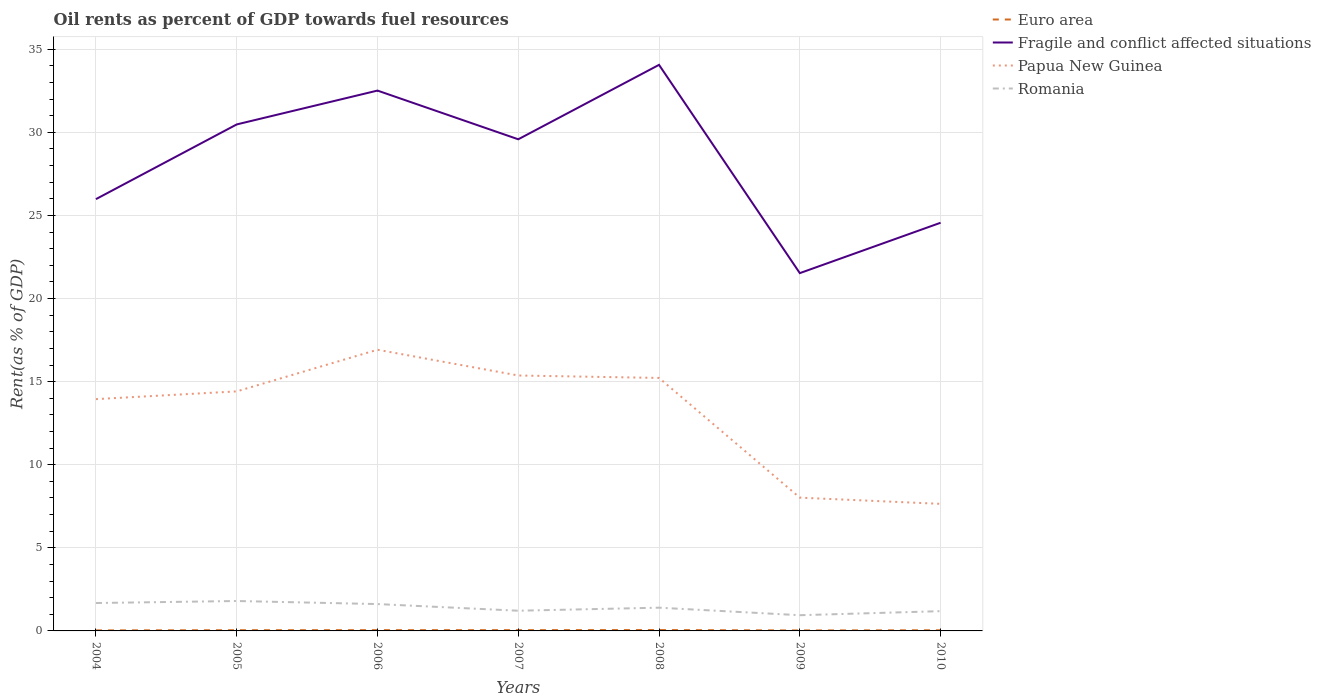Is the number of lines equal to the number of legend labels?
Make the answer very short. Yes. Across all years, what is the maximum oil rent in Euro area?
Keep it short and to the point. 0.03. What is the total oil rent in Papua New Guinea in the graph?
Ensure brevity in your answer.  7.72. What is the difference between the highest and the second highest oil rent in Fragile and conflict affected situations?
Your response must be concise. 12.53. What is the difference between the highest and the lowest oil rent in Fragile and conflict affected situations?
Make the answer very short. 4. Are the values on the major ticks of Y-axis written in scientific E-notation?
Give a very brief answer. No. How are the legend labels stacked?
Provide a succinct answer. Vertical. What is the title of the graph?
Ensure brevity in your answer.  Oil rents as percent of GDP towards fuel resources. Does "Micronesia" appear as one of the legend labels in the graph?
Give a very brief answer. No. What is the label or title of the Y-axis?
Ensure brevity in your answer.  Rent(as % of GDP). What is the Rent(as % of GDP) in Euro area in 2004?
Your answer should be compact. 0.03. What is the Rent(as % of GDP) in Fragile and conflict affected situations in 2004?
Your answer should be compact. 25.98. What is the Rent(as % of GDP) of Papua New Guinea in 2004?
Offer a very short reply. 13.95. What is the Rent(as % of GDP) of Romania in 2004?
Provide a short and direct response. 1.68. What is the Rent(as % of GDP) in Euro area in 2005?
Provide a succinct answer. 0.04. What is the Rent(as % of GDP) in Fragile and conflict affected situations in 2005?
Offer a terse response. 30.48. What is the Rent(as % of GDP) of Papua New Guinea in 2005?
Your answer should be very brief. 14.41. What is the Rent(as % of GDP) in Romania in 2005?
Offer a terse response. 1.8. What is the Rent(as % of GDP) in Euro area in 2006?
Offer a terse response. 0.05. What is the Rent(as % of GDP) in Fragile and conflict affected situations in 2006?
Your response must be concise. 32.51. What is the Rent(as % of GDP) of Papua New Guinea in 2006?
Offer a terse response. 16.92. What is the Rent(as % of GDP) in Romania in 2006?
Offer a terse response. 1.62. What is the Rent(as % of GDP) in Euro area in 2007?
Ensure brevity in your answer.  0.05. What is the Rent(as % of GDP) of Fragile and conflict affected situations in 2007?
Offer a terse response. 29.58. What is the Rent(as % of GDP) of Papua New Guinea in 2007?
Make the answer very short. 15.37. What is the Rent(as % of GDP) of Romania in 2007?
Your answer should be compact. 1.22. What is the Rent(as % of GDP) of Euro area in 2008?
Give a very brief answer. 0.05. What is the Rent(as % of GDP) of Fragile and conflict affected situations in 2008?
Provide a succinct answer. 34.06. What is the Rent(as % of GDP) of Papua New Guinea in 2008?
Offer a very short reply. 15.22. What is the Rent(as % of GDP) in Romania in 2008?
Offer a terse response. 1.4. What is the Rent(as % of GDP) in Euro area in 2009?
Provide a succinct answer. 0.03. What is the Rent(as % of GDP) in Fragile and conflict affected situations in 2009?
Your answer should be very brief. 21.53. What is the Rent(as % of GDP) in Papua New Guinea in 2009?
Offer a very short reply. 8.02. What is the Rent(as % of GDP) in Romania in 2009?
Your response must be concise. 0.95. What is the Rent(as % of GDP) in Euro area in 2010?
Make the answer very short. 0.04. What is the Rent(as % of GDP) in Fragile and conflict affected situations in 2010?
Offer a terse response. 24.56. What is the Rent(as % of GDP) in Papua New Guinea in 2010?
Provide a succinct answer. 7.65. What is the Rent(as % of GDP) of Romania in 2010?
Provide a short and direct response. 1.19. Across all years, what is the maximum Rent(as % of GDP) in Euro area?
Ensure brevity in your answer.  0.05. Across all years, what is the maximum Rent(as % of GDP) in Fragile and conflict affected situations?
Your answer should be very brief. 34.06. Across all years, what is the maximum Rent(as % of GDP) of Papua New Guinea?
Your answer should be very brief. 16.92. Across all years, what is the maximum Rent(as % of GDP) in Romania?
Your answer should be compact. 1.8. Across all years, what is the minimum Rent(as % of GDP) in Euro area?
Provide a succinct answer. 0.03. Across all years, what is the minimum Rent(as % of GDP) in Fragile and conflict affected situations?
Ensure brevity in your answer.  21.53. Across all years, what is the minimum Rent(as % of GDP) in Papua New Guinea?
Provide a short and direct response. 7.65. Across all years, what is the minimum Rent(as % of GDP) of Romania?
Offer a terse response. 0.95. What is the total Rent(as % of GDP) in Euro area in the graph?
Your response must be concise. 0.29. What is the total Rent(as % of GDP) of Fragile and conflict affected situations in the graph?
Ensure brevity in your answer.  198.7. What is the total Rent(as % of GDP) in Papua New Guinea in the graph?
Your response must be concise. 91.53. What is the total Rent(as % of GDP) in Romania in the graph?
Make the answer very short. 9.84. What is the difference between the Rent(as % of GDP) of Euro area in 2004 and that in 2005?
Ensure brevity in your answer.  -0.01. What is the difference between the Rent(as % of GDP) of Fragile and conflict affected situations in 2004 and that in 2005?
Provide a succinct answer. -4.5. What is the difference between the Rent(as % of GDP) of Papua New Guinea in 2004 and that in 2005?
Offer a terse response. -0.47. What is the difference between the Rent(as % of GDP) of Romania in 2004 and that in 2005?
Give a very brief answer. -0.12. What is the difference between the Rent(as % of GDP) in Euro area in 2004 and that in 2006?
Offer a very short reply. -0.02. What is the difference between the Rent(as % of GDP) in Fragile and conflict affected situations in 2004 and that in 2006?
Give a very brief answer. -6.53. What is the difference between the Rent(as % of GDP) in Papua New Guinea in 2004 and that in 2006?
Offer a very short reply. -2.97. What is the difference between the Rent(as % of GDP) in Romania in 2004 and that in 2006?
Keep it short and to the point. 0.06. What is the difference between the Rent(as % of GDP) of Euro area in 2004 and that in 2007?
Provide a short and direct response. -0.02. What is the difference between the Rent(as % of GDP) of Fragile and conflict affected situations in 2004 and that in 2007?
Give a very brief answer. -3.6. What is the difference between the Rent(as % of GDP) of Papua New Guinea in 2004 and that in 2007?
Provide a short and direct response. -1.42. What is the difference between the Rent(as % of GDP) of Romania in 2004 and that in 2007?
Your answer should be very brief. 0.46. What is the difference between the Rent(as % of GDP) in Euro area in 2004 and that in 2008?
Ensure brevity in your answer.  -0.02. What is the difference between the Rent(as % of GDP) of Fragile and conflict affected situations in 2004 and that in 2008?
Make the answer very short. -8.08. What is the difference between the Rent(as % of GDP) in Papua New Guinea in 2004 and that in 2008?
Give a very brief answer. -1.27. What is the difference between the Rent(as % of GDP) of Romania in 2004 and that in 2008?
Make the answer very short. 0.28. What is the difference between the Rent(as % of GDP) of Euro area in 2004 and that in 2009?
Provide a short and direct response. 0. What is the difference between the Rent(as % of GDP) of Fragile and conflict affected situations in 2004 and that in 2009?
Provide a succinct answer. 4.45. What is the difference between the Rent(as % of GDP) in Papua New Guinea in 2004 and that in 2009?
Your answer should be compact. 5.93. What is the difference between the Rent(as % of GDP) in Romania in 2004 and that in 2009?
Your answer should be very brief. 0.73. What is the difference between the Rent(as % of GDP) in Euro area in 2004 and that in 2010?
Ensure brevity in your answer.  -0.01. What is the difference between the Rent(as % of GDP) in Fragile and conflict affected situations in 2004 and that in 2010?
Ensure brevity in your answer.  1.42. What is the difference between the Rent(as % of GDP) of Papua New Guinea in 2004 and that in 2010?
Provide a succinct answer. 6.3. What is the difference between the Rent(as % of GDP) in Romania in 2004 and that in 2010?
Keep it short and to the point. 0.49. What is the difference between the Rent(as % of GDP) in Euro area in 2005 and that in 2006?
Keep it short and to the point. -0. What is the difference between the Rent(as % of GDP) of Fragile and conflict affected situations in 2005 and that in 2006?
Provide a succinct answer. -2.04. What is the difference between the Rent(as % of GDP) in Papua New Guinea in 2005 and that in 2006?
Your answer should be very brief. -2.51. What is the difference between the Rent(as % of GDP) of Romania in 2005 and that in 2006?
Keep it short and to the point. 0.18. What is the difference between the Rent(as % of GDP) of Euro area in 2005 and that in 2007?
Ensure brevity in your answer.  -0. What is the difference between the Rent(as % of GDP) of Fragile and conflict affected situations in 2005 and that in 2007?
Provide a succinct answer. 0.89. What is the difference between the Rent(as % of GDP) of Papua New Guinea in 2005 and that in 2007?
Keep it short and to the point. -0.96. What is the difference between the Rent(as % of GDP) of Romania in 2005 and that in 2007?
Offer a very short reply. 0.58. What is the difference between the Rent(as % of GDP) of Euro area in 2005 and that in 2008?
Make the answer very short. -0.01. What is the difference between the Rent(as % of GDP) of Fragile and conflict affected situations in 2005 and that in 2008?
Offer a very short reply. -3.58. What is the difference between the Rent(as % of GDP) in Papua New Guinea in 2005 and that in 2008?
Provide a succinct answer. -0.81. What is the difference between the Rent(as % of GDP) of Romania in 2005 and that in 2008?
Ensure brevity in your answer.  0.4. What is the difference between the Rent(as % of GDP) of Euro area in 2005 and that in 2009?
Your answer should be compact. 0.01. What is the difference between the Rent(as % of GDP) in Fragile and conflict affected situations in 2005 and that in 2009?
Keep it short and to the point. 8.95. What is the difference between the Rent(as % of GDP) of Papua New Guinea in 2005 and that in 2009?
Keep it short and to the point. 6.39. What is the difference between the Rent(as % of GDP) in Romania in 2005 and that in 2009?
Ensure brevity in your answer.  0.85. What is the difference between the Rent(as % of GDP) in Euro area in 2005 and that in 2010?
Your response must be concise. 0. What is the difference between the Rent(as % of GDP) in Fragile and conflict affected situations in 2005 and that in 2010?
Offer a very short reply. 5.92. What is the difference between the Rent(as % of GDP) of Papua New Guinea in 2005 and that in 2010?
Your response must be concise. 6.77. What is the difference between the Rent(as % of GDP) of Romania in 2005 and that in 2010?
Your answer should be very brief. 0.61. What is the difference between the Rent(as % of GDP) in Euro area in 2006 and that in 2007?
Give a very brief answer. -0. What is the difference between the Rent(as % of GDP) of Fragile and conflict affected situations in 2006 and that in 2007?
Provide a succinct answer. 2.93. What is the difference between the Rent(as % of GDP) in Papua New Guinea in 2006 and that in 2007?
Offer a terse response. 1.55. What is the difference between the Rent(as % of GDP) of Romania in 2006 and that in 2007?
Your answer should be very brief. 0.4. What is the difference between the Rent(as % of GDP) of Euro area in 2006 and that in 2008?
Your answer should be compact. -0.01. What is the difference between the Rent(as % of GDP) of Fragile and conflict affected situations in 2006 and that in 2008?
Offer a very short reply. -1.55. What is the difference between the Rent(as % of GDP) in Papua New Guinea in 2006 and that in 2008?
Keep it short and to the point. 1.7. What is the difference between the Rent(as % of GDP) in Romania in 2006 and that in 2008?
Your response must be concise. 0.22. What is the difference between the Rent(as % of GDP) of Euro area in 2006 and that in 2009?
Ensure brevity in your answer.  0.02. What is the difference between the Rent(as % of GDP) of Fragile and conflict affected situations in 2006 and that in 2009?
Give a very brief answer. 10.98. What is the difference between the Rent(as % of GDP) in Papua New Guinea in 2006 and that in 2009?
Your answer should be very brief. 8.9. What is the difference between the Rent(as % of GDP) in Romania in 2006 and that in 2009?
Give a very brief answer. 0.67. What is the difference between the Rent(as % of GDP) in Euro area in 2006 and that in 2010?
Offer a very short reply. 0.01. What is the difference between the Rent(as % of GDP) of Fragile and conflict affected situations in 2006 and that in 2010?
Provide a short and direct response. 7.95. What is the difference between the Rent(as % of GDP) of Papua New Guinea in 2006 and that in 2010?
Your response must be concise. 9.27. What is the difference between the Rent(as % of GDP) of Romania in 2006 and that in 2010?
Provide a succinct answer. 0.43. What is the difference between the Rent(as % of GDP) in Euro area in 2007 and that in 2008?
Give a very brief answer. -0.01. What is the difference between the Rent(as % of GDP) in Fragile and conflict affected situations in 2007 and that in 2008?
Keep it short and to the point. -4.48. What is the difference between the Rent(as % of GDP) of Papua New Guinea in 2007 and that in 2008?
Provide a succinct answer. 0.15. What is the difference between the Rent(as % of GDP) in Romania in 2007 and that in 2008?
Your response must be concise. -0.18. What is the difference between the Rent(as % of GDP) of Euro area in 2007 and that in 2009?
Ensure brevity in your answer.  0.02. What is the difference between the Rent(as % of GDP) in Fragile and conflict affected situations in 2007 and that in 2009?
Offer a very short reply. 8.05. What is the difference between the Rent(as % of GDP) in Papua New Guinea in 2007 and that in 2009?
Give a very brief answer. 7.35. What is the difference between the Rent(as % of GDP) of Romania in 2007 and that in 2009?
Offer a terse response. 0.27. What is the difference between the Rent(as % of GDP) of Euro area in 2007 and that in 2010?
Provide a succinct answer. 0.01. What is the difference between the Rent(as % of GDP) in Fragile and conflict affected situations in 2007 and that in 2010?
Offer a terse response. 5.02. What is the difference between the Rent(as % of GDP) of Papua New Guinea in 2007 and that in 2010?
Offer a terse response. 7.72. What is the difference between the Rent(as % of GDP) in Romania in 2007 and that in 2010?
Ensure brevity in your answer.  0.03. What is the difference between the Rent(as % of GDP) of Euro area in 2008 and that in 2009?
Provide a short and direct response. 0.02. What is the difference between the Rent(as % of GDP) of Fragile and conflict affected situations in 2008 and that in 2009?
Offer a very short reply. 12.53. What is the difference between the Rent(as % of GDP) in Papua New Guinea in 2008 and that in 2009?
Make the answer very short. 7.2. What is the difference between the Rent(as % of GDP) in Romania in 2008 and that in 2009?
Keep it short and to the point. 0.45. What is the difference between the Rent(as % of GDP) of Euro area in 2008 and that in 2010?
Your answer should be very brief. 0.01. What is the difference between the Rent(as % of GDP) in Fragile and conflict affected situations in 2008 and that in 2010?
Ensure brevity in your answer.  9.5. What is the difference between the Rent(as % of GDP) of Papua New Guinea in 2008 and that in 2010?
Offer a terse response. 7.58. What is the difference between the Rent(as % of GDP) of Romania in 2008 and that in 2010?
Provide a short and direct response. 0.21. What is the difference between the Rent(as % of GDP) in Euro area in 2009 and that in 2010?
Ensure brevity in your answer.  -0.01. What is the difference between the Rent(as % of GDP) of Fragile and conflict affected situations in 2009 and that in 2010?
Offer a terse response. -3.03. What is the difference between the Rent(as % of GDP) in Papua New Guinea in 2009 and that in 2010?
Give a very brief answer. 0.37. What is the difference between the Rent(as % of GDP) of Romania in 2009 and that in 2010?
Your answer should be very brief. -0.24. What is the difference between the Rent(as % of GDP) of Euro area in 2004 and the Rent(as % of GDP) of Fragile and conflict affected situations in 2005?
Provide a succinct answer. -30.44. What is the difference between the Rent(as % of GDP) in Euro area in 2004 and the Rent(as % of GDP) in Papua New Guinea in 2005?
Provide a short and direct response. -14.38. What is the difference between the Rent(as % of GDP) in Euro area in 2004 and the Rent(as % of GDP) in Romania in 2005?
Offer a terse response. -1.77. What is the difference between the Rent(as % of GDP) in Fragile and conflict affected situations in 2004 and the Rent(as % of GDP) in Papua New Guinea in 2005?
Make the answer very short. 11.57. What is the difference between the Rent(as % of GDP) of Fragile and conflict affected situations in 2004 and the Rent(as % of GDP) of Romania in 2005?
Provide a succinct answer. 24.18. What is the difference between the Rent(as % of GDP) in Papua New Guinea in 2004 and the Rent(as % of GDP) in Romania in 2005?
Your answer should be very brief. 12.15. What is the difference between the Rent(as % of GDP) of Euro area in 2004 and the Rent(as % of GDP) of Fragile and conflict affected situations in 2006?
Give a very brief answer. -32.48. What is the difference between the Rent(as % of GDP) in Euro area in 2004 and the Rent(as % of GDP) in Papua New Guinea in 2006?
Keep it short and to the point. -16.89. What is the difference between the Rent(as % of GDP) in Euro area in 2004 and the Rent(as % of GDP) in Romania in 2006?
Your answer should be very brief. -1.58. What is the difference between the Rent(as % of GDP) of Fragile and conflict affected situations in 2004 and the Rent(as % of GDP) of Papua New Guinea in 2006?
Your response must be concise. 9.06. What is the difference between the Rent(as % of GDP) in Fragile and conflict affected situations in 2004 and the Rent(as % of GDP) in Romania in 2006?
Give a very brief answer. 24.36. What is the difference between the Rent(as % of GDP) of Papua New Guinea in 2004 and the Rent(as % of GDP) of Romania in 2006?
Your answer should be compact. 12.33. What is the difference between the Rent(as % of GDP) in Euro area in 2004 and the Rent(as % of GDP) in Fragile and conflict affected situations in 2007?
Your answer should be compact. -29.55. What is the difference between the Rent(as % of GDP) in Euro area in 2004 and the Rent(as % of GDP) in Papua New Guinea in 2007?
Your response must be concise. -15.34. What is the difference between the Rent(as % of GDP) in Euro area in 2004 and the Rent(as % of GDP) in Romania in 2007?
Your answer should be compact. -1.18. What is the difference between the Rent(as % of GDP) in Fragile and conflict affected situations in 2004 and the Rent(as % of GDP) in Papua New Guinea in 2007?
Offer a terse response. 10.61. What is the difference between the Rent(as % of GDP) of Fragile and conflict affected situations in 2004 and the Rent(as % of GDP) of Romania in 2007?
Offer a terse response. 24.77. What is the difference between the Rent(as % of GDP) of Papua New Guinea in 2004 and the Rent(as % of GDP) of Romania in 2007?
Keep it short and to the point. 12.73. What is the difference between the Rent(as % of GDP) of Euro area in 2004 and the Rent(as % of GDP) of Fragile and conflict affected situations in 2008?
Provide a short and direct response. -34.03. What is the difference between the Rent(as % of GDP) of Euro area in 2004 and the Rent(as % of GDP) of Papua New Guinea in 2008?
Provide a succinct answer. -15.19. What is the difference between the Rent(as % of GDP) in Euro area in 2004 and the Rent(as % of GDP) in Romania in 2008?
Offer a very short reply. -1.37. What is the difference between the Rent(as % of GDP) of Fragile and conflict affected situations in 2004 and the Rent(as % of GDP) of Papua New Guinea in 2008?
Provide a short and direct response. 10.76. What is the difference between the Rent(as % of GDP) of Fragile and conflict affected situations in 2004 and the Rent(as % of GDP) of Romania in 2008?
Ensure brevity in your answer.  24.58. What is the difference between the Rent(as % of GDP) in Papua New Guinea in 2004 and the Rent(as % of GDP) in Romania in 2008?
Provide a succinct answer. 12.55. What is the difference between the Rent(as % of GDP) of Euro area in 2004 and the Rent(as % of GDP) of Fragile and conflict affected situations in 2009?
Your response must be concise. -21.5. What is the difference between the Rent(as % of GDP) of Euro area in 2004 and the Rent(as % of GDP) of Papua New Guinea in 2009?
Make the answer very short. -7.99. What is the difference between the Rent(as % of GDP) of Euro area in 2004 and the Rent(as % of GDP) of Romania in 2009?
Offer a terse response. -0.91. What is the difference between the Rent(as % of GDP) in Fragile and conflict affected situations in 2004 and the Rent(as % of GDP) in Papua New Guinea in 2009?
Offer a terse response. 17.96. What is the difference between the Rent(as % of GDP) in Fragile and conflict affected situations in 2004 and the Rent(as % of GDP) in Romania in 2009?
Offer a very short reply. 25.03. What is the difference between the Rent(as % of GDP) in Papua New Guinea in 2004 and the Rent(as % of GDP) in Romania in 2009?
Keep it short and to the point. 13. What is the difference between the Rent(as % of GDP) of Euro area in 2004 and the Rent(as % of GDP) of Fragile and conflict affected situations in 2010?
Provide a succinct answer. -24.53. What is the difference between the Rent(as % of GDP) of Euro area in 2004 and the Rent(as % of GDP) of Papua New Guinea in 2010?
Your answer should be very brief. -7.61. What is the difference between the Rent(as % of GDP) of Euro area in 2004 and the Rent(as % of GDP) of Romania in 2010?
Provide a succinct answer. -1.16. What is the difference between the Rent(as % of GDP) in Fragile and conflict affected situations in 2004 and the Rent(as % of GDP) in Papua New Guinea in 2010?
Make the answer very short. 18.33. What is the difference between the Rent(as % of GDP) of Fragile and conflict affected situations in 2004 and the Rent(as % of GDP) of Romania in 2010?
Provide a succinct answer. 24.79. What is the difference between the Rent(as % of GDP) in Papua New Guinea in 2004 and the Rent(as % of GDP) in Romania in 2010?
Give a very brief answer. 12.76. What is the difference between the Rent(as % of GDP) of Euro area in 2005 and the Rent(as % of GDP) of Fragile and conflict affected situations in 2006?
Keep it short and to the point. -32.47. What is the difference between the Rent(as % of GDP) of Euro area in 2005 and the Rent(as % of GDP) of Papua New Guinea in 2006?
Offer a terse response. -16.88. What is the difference between the Rent(as % of GDP) in Euro area in 2005 and the Rent(as % of GDP) in Romania in 2006?
Give a very brief answer. -1.57. What is the difference between the Rent(as % of GDP) of Fragile and conflict affected situations in 2005 and the Rent(as % of GDP) of Papua New Guinea in 2006?
Make the answer very short. 13.56. What is the difference between the Rent(as % of GDP) in Fragile and conflict affected situations in 2005 and the Rent(as % of GDP) in Romania in 2006?
Provide a succinct answer. 28.86. What is the difference between the Rent(as % of GDP) of Papua New Guinea in 2005 and the Rent(as % of GDP) of Romania in 2006?
Offer a terse response. 12.8. What is the difference between the Rent(as % of GDP) in Euro area in 2005 and the Rent(as % of GDP) in Fragile and conflict affected situations in 2007?
Offer a very short reply. -29.54. What is the difference between the Rent(as % of GDP) of Euro area in 2005 and the Rent(as % of GDP) of Papua New Guinea in 2007?
Keep it short and to the point. -15.33. What is the difference between the Rent(as % of GDP) in Euro area in 2005 and the Rent(as % of GDP) in Romania in 2007?
Offer a very short reply. -1.17. What is the difference between the Rent(as % of GDP) in Fragile and conflict affected situations in 2005 and the Rent(as % of GDP) in Papua New Guinea in 2007?
Ensure brevity in your answer.  15.11. What is the difference between the Rent(as % of GDP) in Fragile and conflict affected situations in 2005 and the Rent(as % of GDP) in Romania in 2007?
Your response must be concise. 29.26. What is the difference between the Rent(as % of GDP) in Papua New Guinea in 2005 and the Rent(as % of GDP) in Romania in 2007?
Your answer should be very brief. 13.2. What is the difference between the Rent(as % of GDP) in Euro area in 2005 and the Rent(as % of GDP) in Fragile and conflict affected situations in 2008?
Offer a terse response. -34.02. What is the difference between the Rent(as % of GDP) in Euro area in 2005 and the Rent(as % of GDP) in Papua New Guinea in 2008?
Make the answer very short. -15.18. What is the difference between the Rent(as % of GDP) of Euro area in 2005 and the Rent(as % of GDP) of Romania in 2008?
Your answer should be very brief. -1.36. What is the difference between the Rent(as % of GDP) of Fragile and conflict affected situations in 2005 and the Rent(as % of GDP) of Papua New Guinea in 2008?
Your response must be concise. 15.25. What is the difference between the Rent(as % of GDP) of Fragile and conflict affected situations in 2005 and the Rent(as % of GDP) of Romania in 2008?
Provide a succinct answer. 29.08. What is the difference between the Rent(as % of GDP) of Papua New Guinea in 2005 and the Rent(as % of GDP) of Romania in 2008?
Your answer should be very brief. 13.01. What is the difference between the Rent(as % of GDP) of Euro area in 2005 and the Rent(as % of GDP) of Fragile and conflict affected situations in 2009?
Your answer should be compact. -21.48. What is the difference between the Rent(as % of GDP) of Euro area in 2005 and the Rent(as % of GDP) of Papua New Guinea in 2009?
Your answer should be very brief. -7.98. What is the difference between the Rent(as % of GDP) of Euro area in 2005 and the Rent(as % of GDP) of Romania in 2009?
Ensure brevity in your answer.  -0.9. What is the difference between the Rent(as % of GDP) of Fragile and conflict affected situations in 2005 and the Rent(as % of GDP) of Papua New Guinea in 2009?
Your answer should be very brief. 22.46. What is the difference between the Rent(as % of GDP) in Fragile and conflict affected situations in 2005 and the Rent(as % of GDP) in Romania in 2009?
Make the answer very short. 29.53. What is the difference between the Rent(as % of GDP) in Papua New Guinea in 2005 and the Rent(as % of GDP) in Romania in 2009?
Your response must be concise. 13.47. What is the difference between the Rent(as % of GDP) in Euro area in 2005 and the Rent(as % of GDP) in Fragile and conflict affected situations in 2010?
Your response must be concise. -24.52. What is the difference between the Rent(as % of GDP) in Euro area in 2005 and the Rent(as % of GDP) in Papua New Guinea in 2010?
Offer a terse response. -7.6. What is the difference between the Rent(as % of GDP) in Euro area in 2005 and the Rent(as % of GDP) in Romania in 2010?
Offer a very short reply. -1.15. What is the difference between the Rent(as % of GDP) in Fragile and conflict affected situations in 2005 and the Rent(as % of GDP) in Papua New Guinea in 2010?
Provide a short and direct response. 22.83. What is the difference between the Rent(as % of GDP) in Fragile and conflict affected situations in 2005 and the Rent(as % of GDP) in Romania in 2010?
Keep it short and to the point. 29.29. What is the difference between the Rent(as % of GDP) of Papua New Guinea in 2005 and the Rent(as % of GDP) of Romania in 2010?
Make the answer very short. 13.22. What is the difference between the Rent(as % of GDP) in Euro area in 2006 and the Rent(as % of GDP) in Fragile and conflict affected situations in 2007?
Ensure brevity in your answer.  -29.53. What is the difference between the Rent(as % of GDP) of Euro area in 2006 and the Rent(as % of GDP) of Papua New Guinea in 2007?
Offer a very short reply. -15.32. What is the difference between the Rent(as % of GDP) in Euro area in 2006 and the Rent(as % of GDP) in Romania in 2007?
Offer a very short reply. -1.17. What is the difference between the Rent(as % of GDP) in Fragile and conflict affected situations in 2006 and the Rent(as % of GDP) in Papua New Guinea in 2007?
Offer a terse response. 17.14. What is the difference between the Rent(as % of GDP) in Fragile and conflict affected situations in 2006 and the Rent(as % of GDP) in Romania in 2007?
Provide a short and direct response. 31.3. What is the difference between the Rent(as % of GDP) of Papua New Guinea in 2006 and the Rent(as % of GDP) of Romania in 2007?
Ensure brevity in your answer.  15.7. What is the difference between the Rent(as % of GDP) in Euro area in 2006 and the Rent(as % of GDP) in Fragile and conflict affected situations in 2008?
Your answer should be very brief. -34.01. What is the difference between the Rent(as % of GDP) in Euro area in 2006 and the Rent(as % of GDP) in Papua New Guinea in 2008?
Offer a very short reply. -15.18. What is the difference between the Rent(as % of GDP) of Euro area in 2006 and the Rent(as % of GDP) of Romania in 2008?
Your answer should be very brief. -1.35. What is the difference between the Rent(as % of GDP) in Fragile and conflict affected situations in 2006 and the Rent(as % of GDP) in Papua New Guinea in 2008?
Your answer should be very brief. 17.29. What is the difference between the Rent(as % of GDP) in Fragile and conflict affected situations in 2006 and the Rent(as % of GDP) in Romania in 2008?
Keep it short and to the point. 31.11. What is the difference between the Rent(as % of GDP) in Papua New Guinea in 2006 and the Rent(as % of GDP) in Romania in 2008?
Give a very brief answer. 15.52. What is the difference between the Rent(as % of GDP) in Euro area in 2006 and the Rent(as % of GDP) in Fragile and conflict affected situations in 2009?
Provide a short and direct response. -21.48. What is the difference between the Rent(as % of GDP) in Euro area in 2006 and the Rent(as % of GDP) in Papua New Guinea in 2009?
Offer a terse response. -7.97. What is the difference between the Rent(as % of GDP) of Euro area in 2006 and the Rent(as % of GDP) of Romania in 2009?
Your response must be concise. -0.9. What is the difference between the Rent(as % of GDP) in Fragile and conflict affected situations in 2006 and the Rent(as % of GDP) in Papua New Guinea in 2009?
Make the answer very short. 24.49. What is the difference between the Rent(as % of GDP) in Fragile and conflict affected situations in 2006 and the Rent(as % of GDP) in Romania in 2009?
Offer a terse response. 31.57. What is the difference between the Rent(as % of GDP) of Papua New Guinea in 2006 and the Rent(as % of GDP) of Romania in 2009?
Provide a short and direct response. 15.97. What is the difference between the Rent(as % of GDP) of Euro area in 2006 and the Rent(as % of GDP) of Fragile and conflict affected situations in 2010?
Provide a short and direct response. -24.51. What is the difference between the Rent(as % of GDP) of Euro area in 2006 and the Rent(as % of GDP) of Papua New Guinea in 2010?
Offer a terse response. -7.6. What is the difference between the Rent(as % of GDP) of Euro area in 2006 and the Rent(as % of GDP) of Romania in 2010?
Your answer should be very brief. -1.14. What is the difference between the Rent(as % of GDP) in Fragile and conflict affected situations in 2006 and the Rent(as % of GDP) in Papua New Guinea in 2010?
Your response must be concise. 24.87. What is the difference between the Rent(as % of GDP) in Fragile and conflict affected situations in 2006 and the Rent(as % of GDP) in Romania in 2010?
Provide a succinct answer. 31.32. What is the difference between the Rent(as % of GDP) of Papua New Guinea in 2006 and the Rent(as % of GDP) of Romania in 2010?
Provide a succinct answer. 15.73. What is the difference between the Rent(as % of GDP) of Euro area in 2007 and the Rent(as % of GDP) of Fragile and conflict affected situations in 2008?
Keep it short and to the point. -34.01. What is the difference between the Rent(as % of GDP) of Euro area in 2007 and the Rent(as % of GDP) of Papua New Guinea in 2008?
Your answer should be compact. -15.18. What is the difference between the Rent(as % of GDP) of Euro area in 2007 and the Rent(as % of GDP) of Romania in 2008?
Provide a succinct answer. -1.35. What is the difference between the Rent(as % of GDP) of Fragile and conflict affected situations in 2007 and the Rent(as % of GDP) of Papua New Guinea in 2008?
Your answer should be very brief. 14.36. What is the difference between the Rent(as % of GDP) of Fragile and conflict affected situations in 2007 and the Rent(as % of GDP) of Romania in 2008?
Provide a succinct answer. 28.18. What is the difference between the Rent(as % of GDP) in Papua New Guinea in 2007 and the Rent(as % of GDP) in Romania in 2008?
Give a very brief answer. 13.97. What is the difference between the Rent(as % of GDP) in Euro area in 2007 and the Rent(as % of GDP) in Fragile and conflict affected situations in 2009?
Your answer should be very brief. -21.48. What is the difference between the Rent(as % of GDP) in Euro area in 2007 and the Rent(as % of GDP) in Papua New Guinea in 2009?
Provide a succinct answer. -7.97. What is the difference between the Rent(as % of GDP) in Euro area in 2007 and the Rent(as % of GDP) in Romania in 2009?
Make the answer very short. -0.9. What is the difference between the Rent(as % of GDP) in Fragile and conflict affected situations in 2007 and the Rent(as % of GDP) in Papua New Guinea in 2009?
Your answer should be compact. 21.56. What is the difference between the Rent(as % of GDP) of Fragile and conflict affected situations in 2007 and the Rent(as % of GDP) of Romania in 2009?
Ensure brevity in your answer.  28.64. What is the difference between the Rent(as % of GDP) in Papua New Guinea in 2007 and the Rent(as % of GDP) in Romania in 2009?
Provide a short and direct response. 14.42. What is the difference between the Rent(as % of GDP) of Euro area in 2007 and the Rent(as % of GDP) of Fragile and conflict affected situations in 2010?
Offer a very short reply. -24.51. What is the difference between the Rent(as % of GDP) in Euro area in 2007 and the Rent(as % of GDP) in Papua New Guinea in 2010?
Provide a succinct answer. -7.6. What is the difference between the Rent(as % of GDP) of Euro area in 2007 and the Rent(as % of GDP) of Romania in 2010?
Your answer should be compact. -1.14. What is the difference between the Rent(as % of GDP) of Fragile and conflict affected situations in 2007 and the Rent(as % of GDP) of Papua New Guinea in 2010?
Ensure brevity in your answer.  21.94. What is the difference between the Rent(as % of GDP) of Fragile and conflict affected situations in 2007 and the Rent(as % of GDP) of Romania in 2010?
Make the answer very short. 28.39. What is the difference between the Rent(as % of GDP) in Papua New Guinea in 2007 and the Rent(as % of GDP) in Romania in 2010?
Give a very brief answer. 14.18. What is the difference between the Rent(as % of GDP) in Euro area in 2008 and the Rent(as % of GDP) in Fragile and conflict affected situations in 2009?
Your answer should be very brief. -21.47. What is the difference between the Rent(as % of GDP) in Euro area in 2008 and the Rent(as % of GDP) in Papua New Guinea in 2009?
Offer a very short reply. -7.97. What is the difference between the Rent(as % of GDP) in Euro area in 2008 and the Rent(as % of GDP) in Romania in 2009?
Make the answer very short. -0.89. What is the difference between the Rent(as % of GDP) of Fragile and conflict affected situations in 2008 and the Rent(as % of GDP) of Papua New Guinea in 2009?
Keep it short and to the point. 26.04. What is the difference between the Rent(as % of GDP) in Fragile and conflict affected situations in 2008 and the Rent(as % of GDP) in Romania in 2009?
Offer a very short reply. 33.11. What is the difference between the Rent(as % of GDP) of Papua New Guinea in 2008 and the Rent(as % of GDP) of Romania in 2009?
Keep it short and to the point. 14.28. What is the difference between the Rent(as % of GDP) of Euro area in 2008 and the Rent(as % of GDP) of Fragile and conflict affected situations in 2010?
Offer a terse response. -24.51. What is the difference between the Rent(as % of GDP) in Euro area in 2008 and the Rent(as % of GDP) in Papua New Guinea in 2010?
Keep it short and to the point. -7.59. What is the difference between the Rent(as % of GDP) in Euro area in 2008 and the Rent(as % of GDP) in Romania in 2010?
Your answer should be compact. -1.14. What is the difference between the Rent(as % of GDP) in Fragile and conflict affected situations in 2008 and the Rent(as % of GDP) in Papua New Guinea in 2010?
Your response must be concise. 26.41. What is the difference between the Rent(as % of GDP) of Fragile and conflict affected situations in 2008 and the Rent(as % of GDP) of Romania in 2010?
Ensure brevity in your answer.  32.87. What is the difference between the Rent(as % of GDP) of Papua New Guinea in 2008 and the Rent(as % of GDP) of Romania in 2010?
Offer a very short reply. 14.03. What is the difference between the Rent(as % of GDP) in Euro area in 2009 and the Rent(as % of GDP) in Fragile and conflict affected situations in 2010?
Offer a very short reply. -24.53. What is the difference between the Rent(as % of GDP) in Euro area in 2009 and the Rent(as % of GDP) in Papua New Guinea in 2010?
Your answer should be very brief. -7.62. What is the difference between the Rent(as % of GDP) in Euro area in 2009 and the Rent(as % of GDP) in Romania in 2010?
Make the answer very short. -1.16. What is the difference between the Rent(as % of GDP) in Fragile and conflict affected situations in 2009 and the Rent(as % of GDP) in Papua New Guinea in 2010?
Give a very brief answer. 13.88. What is the difference between the Rent(as % of GDP) in Fragile and conflict affected situations in 2009 and the Rent(as % of GDP) in Romania in 2010?
Provide a succinct answer. 20.34. What is the difference between the Rent(as % of GDP) of Papua New Guinea in 2009 and the Rent(as % of GDP) of Romania in 2010?
Offer a very short reply. 6.83. What is the average Rent(as % of GDP) in Euro area per year?
Ensure brevity in your answer.  0.04. What is the average Rent(as % of GDP) in Fragile and conflict affected situations per year?
Offer a very short reply. 28.39. What is the average Rent(as % of GDP) in Papua New Guinea per year?
Provide a short and direct response. 13.08. What is the average Rent(as % of GDP) in Romania per year?
Your answer should be compact. 1.41. In the year 2004, what is the difference between the Rent(as % of GDP) of Euro area and Rent(as % of GDP) of Fragile and conflict affected situations?
Your answer should be very brief. -25.95. In the year 2004, what is the difference between the Rent(as % of GDP) in Euro area and Rent(as % of GDP) in Papua New Guinea?
Provide a short and direct response. -13.92. In the year 2004, what is the difference between the Rent(as % of GDP) in Euro area and Rent(as % of GDP) in Romania?
Offer a terse response. -1.65. In the year 2004, what is the difference between the Rent(as % of GDP) in Fragile and conflict affected situations and Rent(as % of GDP) in Papua New Guinea?
Offer a very short reply. 12.03. In the year 2004, what is the difference between the Rent(as % of GDP) of Fragile and conflict affected situations and Rent(as % of GDP) of Romania?
Provide a short and direct response. 24.3. In the year 2004, what is the difference between the Rent(as % of GDP) in Papua New Guinea and Rent(as % of GDP) in Romania?
Offer a very short reply. 12.27. In the year 2005, what is the difference between the Rent(as % of GDP) in Euro area and Rent(as % of GDP) in Fragile and conflict affected situations?
Make the answer very short. -30.43. In the year 2005, what is the difference between the Rent(as % of GDP) of Euro area and Rent(as % of GDP) of Papua New Guinea?
Your answer should be compact. -14.37. In the year 2005, what is the difference between the Rent(as % of GDP) in Euro area and Rent(as % of GDP) in Romania?
Offer a terse response. -1.76. In the year 2005, what is the difference between the Rent(as % of GDP) of Fragile and conflict affected situations and Rent(as % of GDP) of Papua New Guinea?
Keep it short and to the point. 16.06. In the year 2005, what is the difference between the Rent(as % of GDP) of Fragile and conflict affected situations and Rent(as % of GDP) of Romania?
Your answer should be compact. 28.68. In the year 2005, what is the difference between the Rent(as % of GDP) in Papua New Guinea and Rent(as % of GDP) in Romania?
Offer a terse response. 12.61. In the year 2006, what is the difference between the Rent(as % of GDP) in Euro area and Rent(as % of GDP) in Fragile and conflict affected situations?
Keep it short and to the point. -32.47. In the year 2006, what is the difference between the Rent(as % of GDP) of Euro area and Rent(as % of GDP) of Papua New Guinea?
Give a very brief answer. -16.87. In the year 2006, what is the difference between the Rent(as % of GDP) in Euro area and Rent(as % of GDP) in Romania?
Give a very brief answer. -1.57. In the year 2006, what is the difference between the Rent(as % of GDP) in Fragile and conflict affected situations and Rent(as % of GDP) in Papua New Guinea?
Provide a succinct answer. 15.59. In the year 2006, what is the difference between the Rent(as % of GDP) of Fragile and conflict affected situations and Rent(as % of GDP) of Romania?
Your response must be concise. 30.9. In the year 2006, what is the difference between the Rent(as % of GDP) in Papua New Guinea and Rent(as % of GDP) in Romania?
Give a very brief answer. 15.3. In the year 2007, what is the difference between the Rent(as % of GDP) of Euro area and Rent(as % of GDP) of Fragile and conflict affected situations?
Offer a terse response. -29.53. In the year 2007, what is the difference between the Rent(as % of GDP) of Euro area and Rent(as % of GDP) of Papua New Guinea?
Keep it short and to the point. -15.32. In the year 2007, what is the difference between the Rent(as % of GDP) of Euro area and Rent(as % of GDP) of Romania?
Offer a very short reply. -1.17. In the year 2007, what is the difference between the Rent(as % of GDP) in Fragile and conflict affected situations and Rent(as % of GDP) in Papua New Guinea?
Your answer should be very brief. 14.21. In the year 2007, what is the difference between the Rent(as % of GDP) in Fragile and conflict affected situations and Rent(as % of GDP) in Romania?
Your response must be concise. 28.37. In the year 2007, what is the difference between the Rent(as % of GDP) in Papua New Guinea and Rent(as % of GDP) in Romania?
Provide a short and direct response. 14.15. In the year 2008, what is the difference between the Rent(as % of GDP) in Euro area and Rent(as % of GDP) in Fragile and conflict affected situations?
Offer a very short reply. -34.01. In the year 2008, what is the difference between the Rent(as % of GDP) of Euro area and Rent(as % of GDP) of Papua New Guinea?
Your answer should be compact. -15.17. In the year 2008, what is the difference between the Rent(as % of GDP) of Euro area and Rent(as % of GDP) of Romania?
Provide a short and direct response. -1.35. In the year 2008, what is the difference between the Rent(as % of GDP) in Fragile and conflict affected situations and Rent(as % of GDP) in Papua New Guinea?
Provide a succinct answer. 18.84. In the year 2008, what is the difference between the Rent(as % of GDP) of Fragile and conflict affected situations and Rent(as % of GDP) of Romania?
Offer a terse response. 32.66. In the year 2008, what is the difference between the Rent(as % of GDP) of Papua New Guinea and Rent(as % of GDP) of Romania?
Your answer should be compact. 13.82. In the year 2009, what is the difference between the Rent(as % of GDP) of Euro area and Rent(as % of GDP) of Fragile and conflict affected situations?
Provide a short and direct response. -21.5. In the year 2009, what is the difference between the Rent(as % of GDP) of Euro area and Rent(as % of GDP) of Papua New Guinea?
Make the answer very short. -7.99. In the year 2009, what is the difference between the Rent(as % of GDP) of Euro area and Rent(as % of GDP) of Romania?
Give a very brief answer. -0.92. In the year 2009, what is the difference between the Rent(as % of GDP) of Fragile and conflict affected situations and Rent(as % of GDP) of Papua New Guinea?
Your response must be concise. 13.51. In the year 2009, what is the difference between the Rent(as % of GDP) in Fragile and conflict affected situations and Rent(as % of GDP) in Romania?
Provide a short and direct response. 20.58. In the year 2009, what is the difference between the Rent(as % of GDP) of Papua New Guinea and Rent(as % of GDP) of Romania?
Offer a terse response. 7.07. In the year 2010, what is the difference between the Rent(as % of GDP) of Euro area and Rent(as % of GDP) of Fragile and conflict affected situations?
Keep it short and to the point. -24.52. In the year 2010, what is the difference between the Rent(as % of GDP) in Euro area and Rent(as % of GDP) in Papua New Guinea?
Offer a very short reply. -7.61. In the year 2010, what is the difference between the Rent(as % of GDP) of Euro area and Rent(as % of GDP) of Romania?
Your answer should be compact. -1.15. In the year 2010, what is the difference between the Rent(as % of GDP) in Fragile and conflict affected situations and Rent(as % of GDP) in Papua New Guinea?
Your answer should be very brief. 16.91. In the year 2010, what is the difference between the Rent(as % of GDP) of Fragile and conflict affected situations and Rent(as % of GDP) of Romania?
Offer a terse response. 23.37. In the year 2010, what is the difference between the Rent(as % of GDP) in Papua New Guinea and Rent(as % of GDP) in Romania?
Provide a short and direct response. 6.46. What is the ratio of the Rent(as % of GDP) of Euro area in 2004 to that in 2005?
Offer a very short reply. 0.72. What is the ratio of the Rent(as % of GDP) in Fragile and conflict affected situations in 2004 to that in 2005?
Your answer should be compact. 0.85. What is the ratio of the Rent(as % of GDP) of Romania in 2004 to that in 2005?
Your response must be concise. 0.93. What is the ratio of the Rent(as % of GDP) in Euro area in 2004 to that in 2006?
Keep it short and to the point. 0.67. What is the ratio of the Rent(as % of GDP) of Fragile and conflict affected situations in 2004 to that in 2006?
Your response must be concise. 0.8. What is the ratio of the Rent(as % of GDP) in Papua New Guinea in 2004 to that in 2006?
Provide a short and direct response. 0.82. What is the ratio of the Rent(as % of GDP) of Romania in 2004 to that in 2006?
Provide a short and direct response. 1.04. What is the ratio of the Rent(as % of GDP) of Euro area in 2004 to that in 2007?
Provide a short and direct response. 0.66. What is the ratio of the Rent(as % of GDP) of Fragile and conflict affected situations in 2004 to that in 2007?
Offer a very short reply. 0.88. What is the ratio of the Rent(as % of GDP) in Papua New Guinea in 2004 to that in 2007?
Keep it short and to the point. 0.91. What is the ratio of the Rent(as % of GDP) of Romania in 2004 to that in 2007?
Your response must be concise. 1.38. What is the ratio of the Rent(as % of GDP) in Euro area in 2004 to that in 2008?
Your answer should be compact. 0.59. What is the ratio of the Rent(as % of GDP) of Fragile and conflict affected situations in 2004 to that in 2008?
Your response must be concise. 0.76. What is the ratio of the Rent(as % of GDP) of Papua New Guinea in 2004 to that in 2008?
Offer a very short reply. 0.92. What is the ratio of the Rent(as % of GDP) in Euro area in 2004 to that in 2009?
Your answer should be very brief. 1.08. What is the ratio of the Rent(as % of GDP) in Fragile and conflict affected situations in 2004 to that in 2009?
Your answer should be compact. 1.21. What is the ratio of the Rent(as % of GDP) of Papua New Guinea in 2004 to that in 2009?
Your response must be concise. 1.74. What is the ratio of the Rent(as % of GDP) in Romania in 2004 to that in 2009?
Your answer should be very brief. 1.77. What is the ratio of the Rent(as % of GDP) of Euro area in 2004 to that in 2010?
Offer a terse response. 0.8. What is the ratio of the Rent(as % of GDP) of Fragile and conflict affected situations in 2004 to that in 2010?
Provide a short and direct response. 1.06. What is the ratio of the Rent(as % of GDP) in Papua New Guinea in 2004 to that in 2010?
Your response must be concise. 1.82. What is the ratio of the Rent(as % of GDP) of Romania in 2004 to that in 2010?
Your response must be concise. 1.41. What is the ratio of the Rent(as % of GDP) of Euro area in 2005 to that in 2006?
Ensure brevity in your answer.  0.92. What is the ratio of the Rent(as % of GDP) of Fragile and conflict affected situations in 2005 to that in 2006?
Provide a short and direct response. 0.94. What is the ratio of the Rent(as % of GDP) in Papua New Guinea in 2005 to that in 2006?
Provide a short and direct response. 0.85. What is the ratio of the Rent(as % of GDP) of Romania in 2005 to that in 2006?
Provide a succinct answer. 1.11. What is the ratio of the Rent(as % of GDP) in Euro area in 2005 to that in 2007?
Make the answer very short. 0.92. What is the ratio of the Rent(as % of GDP) of Fragile and conflict affected situations in 2005 to that in 2007?
Keep it short and to the point. 1.03. What is the ratio of the Rent(as % of GDP) of Papua New Guinea in 2005 to that in 2007?
Provide a succinct answer. 0.94. What is the ratio of the Rent(as % of GDP) of Romania in 2005 to that in 2007?
Make the answer very short. 1.48. What is the ratio of the Rent(as % of GDP) of Euro area in 2005 to that in 2008?
Offer a very short reply. 0.81. What is the ratio of the Rent(as % of GDP) in Fragile and conflict affected situations in 2005 to that in 2008?
Make the answer very short. 0.89. What is the ratio of the Rent(as % of GDP) of Papua New Guinea in 2005 to that in 2008?
Ensure brevity in your answer.  0.95. What is the ratio of the Rent(as % of GDP) in Romania in 2005 to that in 2008?
Offer a terse response. 1.29. What is the ratio of the Rent(as % of GDP) of Euro area in 2005 to that in 2009?
Your response must be concise. 1.5. What is the ratio of the Rent(as % of GDP) in Fragile and conflict affected situations in 2005 to that in 2009?
Keep it short and to the point. 1.42. What is the ratio of the Rent(as % of GDP) of Papua New Guinea in 2005 to that in 2009?
Make the answer very short. 1.8. What is the ratio of the Rent(as % of GDP) in Romania in 2005 to that in 2009?
Give a very brief answer. 1.9. What is the ratio of the Rent(as % of GDP) in Euro area in 2005 to that in 2010?
Your answer should be very brief. 1.11. What is the ratio of the Rent(as % of GDP) of Fragile and conflict affected situations in 2005 to that in 2010?
Keep it short and to the point. 1.24. What is the ratio of the Rent(as % of GDP) in Papua New Guinea in 2005 to that in 2010?
Your answer should be compact. 1.89. What is the ratio of the Rent(as % of GDP) of Romania in 2005 to that in 2010?
Ensure brevity in your answer.  1.51. What is the ratio of the Rent(as % of GDP) of Fragile and conflict affected situations in 2006 to that in 2007?
Your response must be concise. 1.1. What is the ratio of the Rent(as % of GDP) of Papua New Guinea in 2006 to that in 2007?
Keep it short and to the point. 1.1. What is the ratio of the Rent(as % of GDP) in Romania in 2006 to that in 2007?
Your response must be concise. 1.33. What is the ratio of the Rent(as % of GDP) in Euro area in 2006 to that in 2008?
Provide a short and direct response. 0.88. What is the ratio of the Rent(as % of GDP) of Fragile and conflict affected situations in 2006 to that in 2008?
Make the answer very short. 0.95. What is the ratio of the Rent(as % of GDP) in Papua New Guinea in 2006 to that in 2008?
Your answer should be very brief. 1.11. What is the ratio of the Rent(as % of GDP) in Romania in 2006 to that in 2008?
Offer a very short reply. 1.16. What is the ratio of the Rent(as % of GDP) in Euro area in 2006 to that in 2009?
Your response must be concise. 1.62. What is the ratio of the Rent(as % of GDP) of Fragile and conflict affected situations in 2006 to that in 2009?
Your answer should be very brief. 1.51. What is the ratio of the Rent(as % of GDP) in Papua New Guinea in 2006 to that in 2009?
Keep it short and to the point. 2.11. What is the ratio of the Rent(as % of GDP) of Romania in 2006 to that in 2009?
Provide a succinct answer. 1.71. What is the ratio of the Rent(as % of GDP) in Euro area in 2006 to that in 2010?
Provide a succinct answer. 1.2. What is the ratio of the Rent(as % of GDP) in Fragile and conflict affected situations in 2006 to that in 2010?
Your answer should be compact. 1.32. What is the ratio of the Rent(as % of GDP) in Papua New Guinea in 2006 to that in 2010?
Provide a short and direct response. 2.21. What is the ratio of the Rent(as % of GDP) in Romania in 2006 to that in 2010?
Give a very brief answer. 1.36. What is the ratio of the Rent(as % of GDP) of Euro area in 2007 to that in 2008?
Offer a terse response. 0.88. What is the ratio of the Rent(as % of GDP) in Fragile and conflict affected situations in 2007 to that in 2008?
Ensure brevity in your answer.  0.87. What is the ratio of the Rent(as % of GDP) in Papua New Guinea in 2007 to that in 2008?
Your response must be concise. 1.01. What is the ratio of the Rent(as % of GDP) of Romania in 2007 to that in 2008?
Keep it short and to the point. 0.87. What is the ratio of the Rent(as % of GDP) in Euro area in 2007 to that in 2009?
Make the answer very short. 1.63. What is the ratio of the Rent(as % of GDP) in Fragile and conflict affected situations in 2007 to that in 2009?
Offer a terse response. 1.37. What is the ratio of the Rent(as % of GDP) in Papua New Guinea in 2007 to that in 2009?
Your answer should be compact. 1.92. What is the ratio of the Rent(as % of GDP) of Romania in 2007 to that in 2009?
Make the answer very short. 1.28. What is the ratio of the Rent(as % of GDP) in Euro area in 2007 to that in 2010?
Offer a terse response. 1.2. What is the ratio of the Rent(as % of GDP) in Fragile and conflict affected situations in 2007 to that in 2010?
Offer a terse response. 1.2. What is the ratio of the Rent(as % of GDP) of Papua New Guinea in 2007 to that in 2010?
Ensure brevity in your answer.  2.01. What is the ratio of the Rent(as % of GDP) of Romania in 2007 to that in 2010?
Offer a terse response. 1.02. What is the ratio of the Rent(as % of GDP) of Euro area in 2008 to that in 2009?
Give a very brief answer. 1.84. What is the ratio of the Rent(as % of GDP) of Fragile and conflict affected situations in 2008 to that in 2009?
Ensure brevity in your answer.  1.58. What is the ratio of the Rent(as % of GDP) in Papua New Guinea in 2008 to that in 2009?
Provide a short and direct response. 1.9. What is the ratio of the Rent(as % of GDP) in Romania in 2008 to that in 2009?
Your response must be concise. 1.48. What is the ratio of the Rent(as % of GDP) of Euro area in 2008 to that in 2010?
Your answer should be very brief. 1.36. What is the ratio of the Rent(as % of GDP) of Fragile and conflict affected situations in 2008 to that in 2010?
Provide a succinct answer. 1.39. What is the ratio of the Rent(as % of GDP) of Papua New Guinea in 2008 to that in 2010?
Provide a short and direct response. 1.99. What is the ratio of the Rent(as % of GDP) of Romania in 2008 to that in 2010?
Your response must be concise. 1.18. What is the ratio of the Rent(as % of GDP) in Euro area in 2009 to that in 2010?
Offer a terse response. 0.74. What is the ratio of the Rent(as % of GDP) in Fragile and conflict affected situations in 2009 to that in 2010?
Keep it short and to the point. 0.88. What is the ratio of the Rent(as % of GDP) in Papua New Guinea in 2009 to that in 2010?
Your answer should be compact. 1.05. What is the ratio of the Rent(as % of GDP) of Romania in 2009 to that in 2010?
Your answer should be compact. 0.8. What is the difference between the highest and the second highest Rent(as % of GDP) in Euro area?
Offer a very short reply. 0.01. What is the difference between the highest and the second highest Rent(as % of GDP) in Fragile and conflict affected situations?
Make the answer very short. 1.55. What is the difference between the highest and the second highest Rent(as % of GDP) in Papua New Guinea?
Your answer should be compact. 1.55. What is the difference between the highest and the second highest Rent(as % of GDP) in Romania?
Your response must be concise. 0.12. What is the difference between the highest and the lowest Rent(as % of GDP) of Euro area?
Give a very brief answer. 0.02. What is the difference between the highest and the lowest Rent(as % of GDP) of Fragile and conflict affected situations?
Provide a succinct answer. 12.53. What is the difference between the highest and the lowest Rent(as % of GDP) in Papua New Guinea?
Give a very brief answer. 9.27. What is the difference between the highest and the lowest Rent(as % of GDP) in Romania?
Keep it short and to the point. 0.85. 